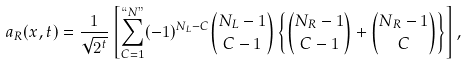Convert formula to latex. <formula><loc_0><loc_0><loc_500><loc_500>a _ { R } ( x , t ) = \frac { 1 } { \sqrt { 2 ^ { t } } } \left [ \sum _ { C = 1 } ^ { ` ` N " } ( - 1 ) ^ { N _ { L } - C } \binom { N _ { L } - 1 } { C - 1 } \left \{ \binom { N _ { R } - 1 } { C - 1 } + \binom { N _ { R } - 1 } { C } \right \} \right ] ,</formula> 